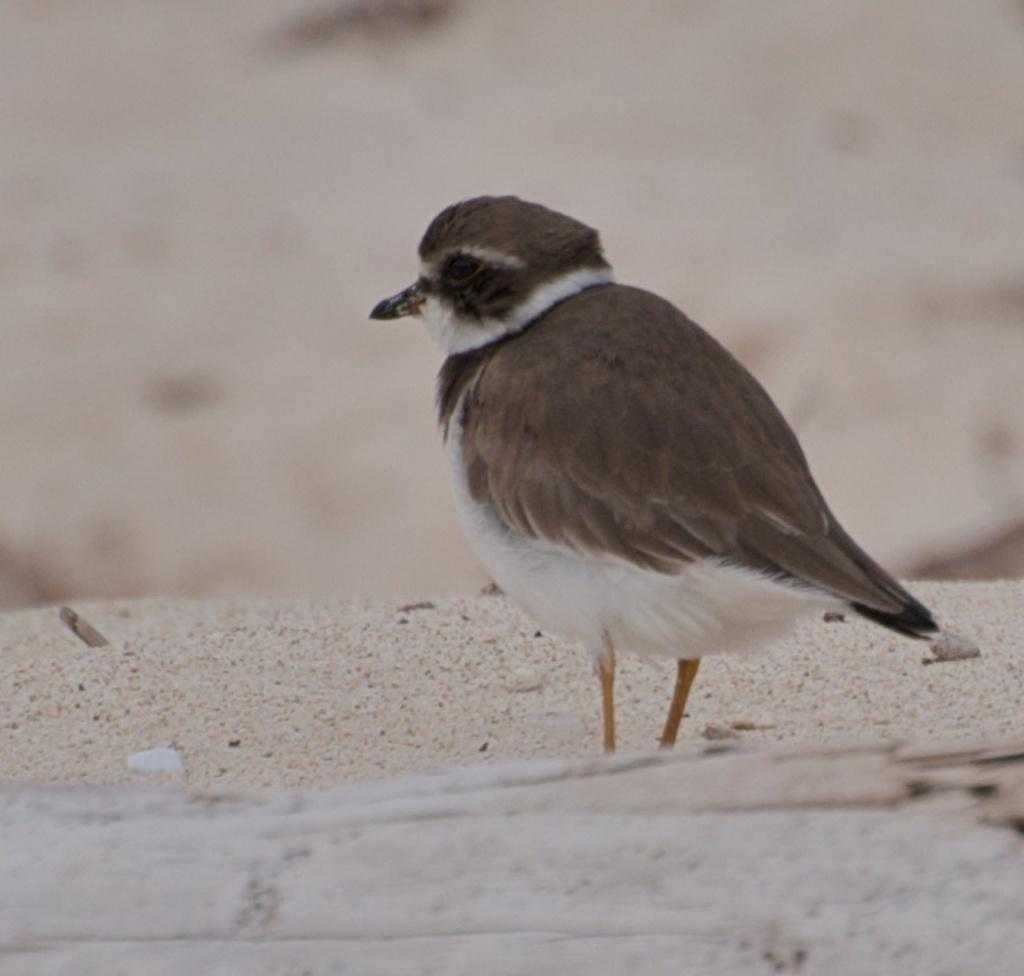What type of animal is in the image? There is a bird in the image. Can you describe the bird's coloring? The bird is brown, black, cream, and orange in color. What is the bird's position in the image? The bird is standing on the ground. How would you describe the background of the image? The background of the image is blurry. How much money does the bird have in the image? There is no indication of money in the image; it features a bird standing on the ground. What does the bird believe in the image? There is no information about the bird's beliefs in the image. 